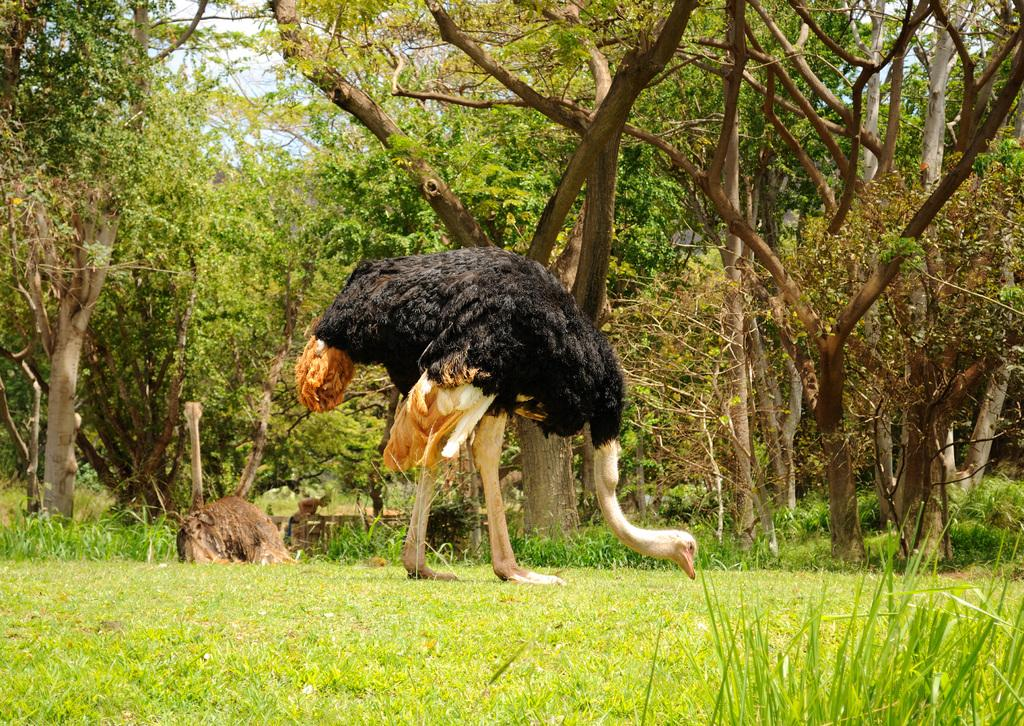What is the main subject in the center of the image? There is an ostrich in the center of the image. Can you describe the appearance of the ostrich? The ostrich is in cream and black color. What can be seen in the background of the image? There is a sky, trees, grass, and a person standing in the background of the image. Are there any other animals visible in the image? Yes, there is at least one animal in the background of the image. What type of disease is the ostrich suffering from in the image? There is no indication in the image that the ostrich is suffering from any disease. What type of coach is present in the image? There is no coach present in the image. 